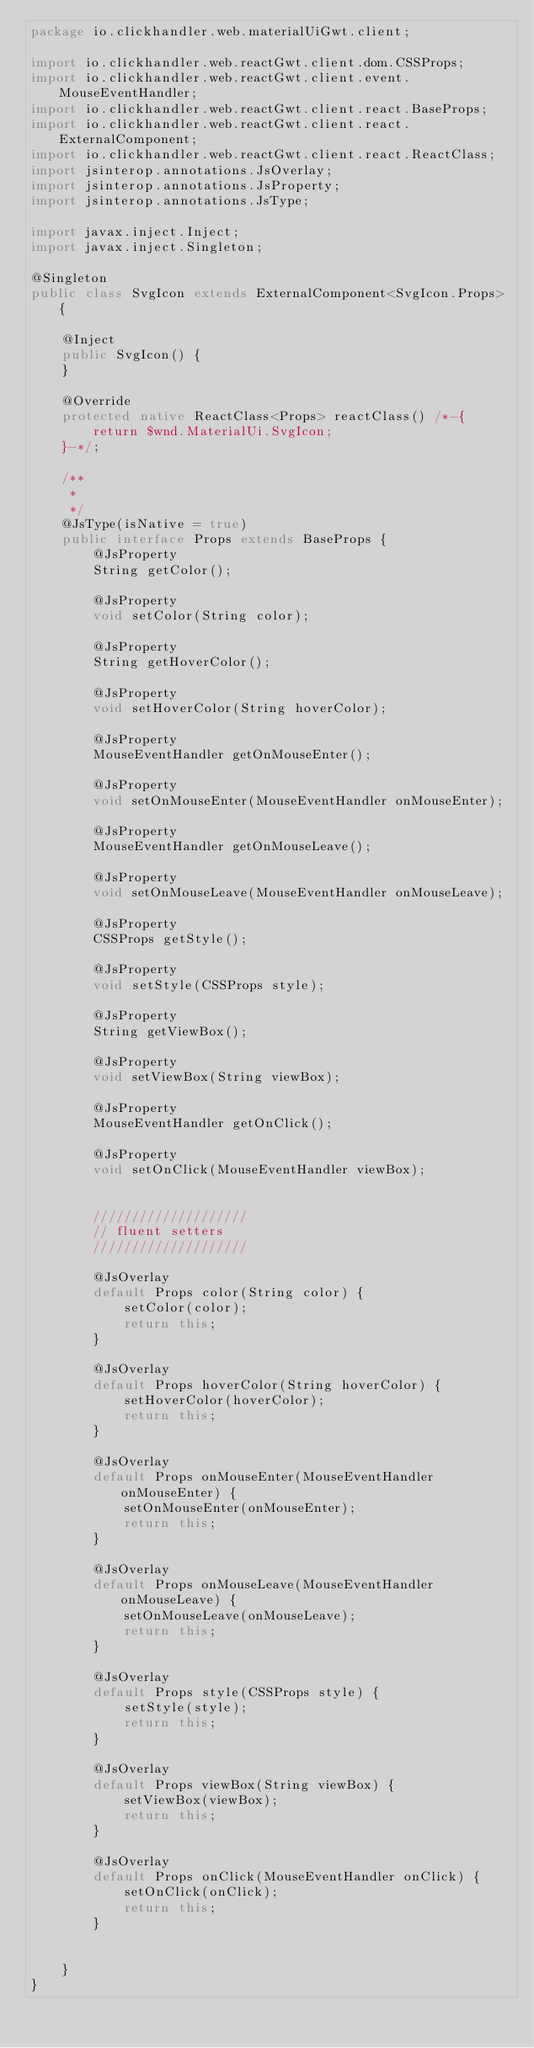<code> <loc_0><loc_0><loc_500><loc_500><_Java_>package io.clickhandler.web.materialUiGwt.client;

import io.clickhandler.web.reactGwt.client.dom.CSSProps;
import io.clickhandler.web.reactGwt.client.event.MouseEventHandler;
import io.clickhandler.web.reactGwt.client.react.BaseProps;
import io.clickhandler.web.reactGwt.client.react.ExternalComponent;
import io.clickhandler.web.reactGwt.client.react.ReactClass;
import jsinterop.annotations.JsOverlay;
import jsinterop.annotations.JsProperty;
import jsinterop.annotations.JsType;

import javax.inject.Inject;
import javax.inject.Singleton;

@Singleton
public class SvgIcon extends ExternalComponent<SvgIcon.Props> {

    @Inject
    public SvgIcon() {
    }

    @Override
    protected native ReactClass<Props> reactClass() /*-{
        return $wnd.MaterialUi.SvgIcon;
    }-*/;

    /**
     *
     */
    @JsType(isNative = true)
    public interface Props extends BaseProps {
        @JsProperty
        String getColor();

        @JsProperty
        void setColor(String color);

        @JsProperty
        String getHoverColor();

        @JsProperty
        void setHoverColor(String hoverColor);

        @JsProperty
        MouseEventHandler getOnMouseEnter();

        @JsProperty
        void setOnMouseEnter(MouseEventHandler onMouseEnter);

        @JsProperty
        MouseEventHandler getOnMouseLeave();

        @JsProperty
        void setOnMouseLeave(MouseEventHandler onMouseLeave);

        @JsProperty
        CSSProps getStyle();

        @JsProperty
        void setStyle(CSSProps style);

        @JsProperty
        String getViewBox();

        @JsProperty
        void setViewBox(String viewBox);

        @JsProperty
        MouseEventHandler getOnClick();

        @JsProperty
        void setOnClick(MouseEventHandler viewBox);


        ////////////////////
        // fluent setters
        ////////////////////

        @JsOverlay
        default Props color(String color) {
            setColor(color);
            return this;
        }

        @JsOverlay
        default Props hoverColor(String hoverColor) {
            setHoverColor(hoverColor);
            return this;
        }

        @JsOverlay
        default Props onMouseEnter(MouseEventHandler onMouseEnter) {
            setOnMouseEnter(onMouseEnter);
            return this;
        }

        @JsOverlay
        default Props onMouseLeave(MouseEventHandler onMouseLeave) {
            setOnMouseLeave(onMouseLeave);
            return this;
        }

        @JsOverlay
        default Props style(CSSProps style) {
            setStyle(style);
            return this;
        }

        @JsOverlay
        default Props viewBox(String viewBox) {
            setViewBox(viewBox);
            return this;
        }

        @JsOverlay
        default Props onClick(MouseEventHandler onClick) {
            setOnClick(onClick);
            return this;
        }


    }
}
</code> 